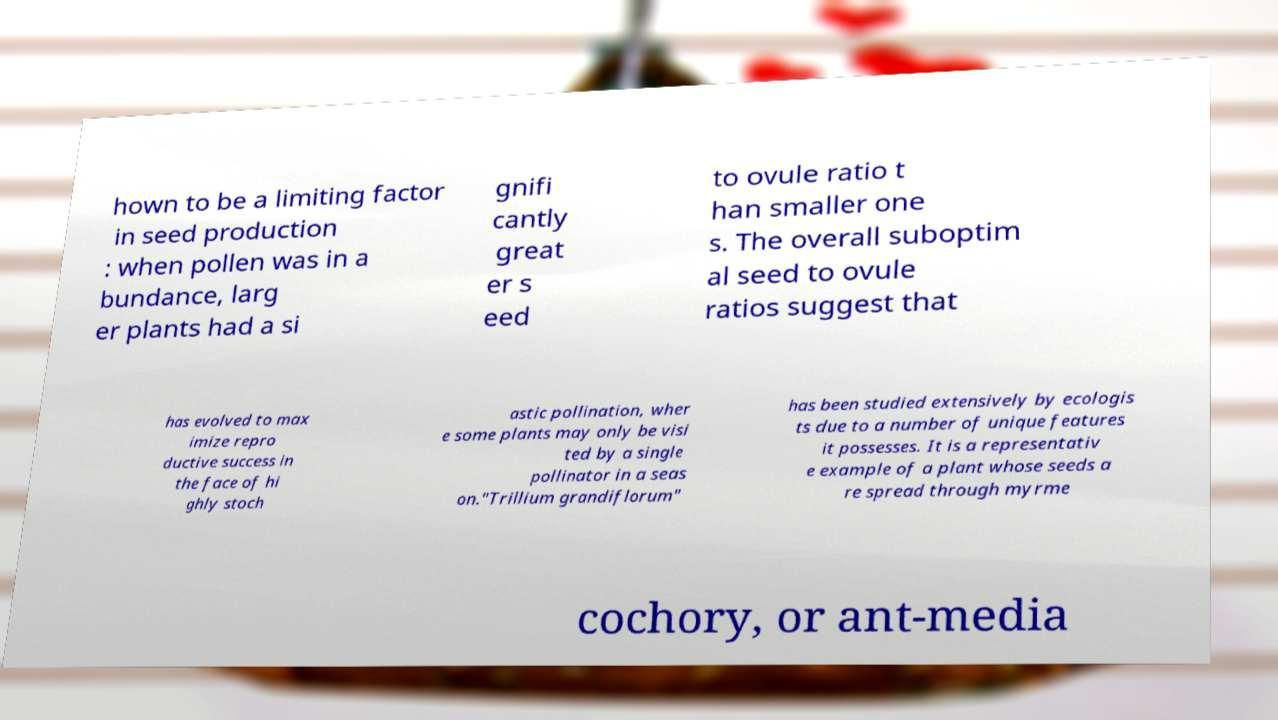What messages or text are displayed in this image? I need them in a readable, typed format. hown to be a limiting factor in seed production : when pollen was in a bundance, larg er plants had a si gnifi cantly great er s eed to ovule ratio t han smaller one s. The overall suboptim al seed to ovule ratios suggest that has evolved to max imize repro ductive success in the face of hi ghly stoch astic pollination, wher e some plants may only be visi ted by a single pollinator in a seas on."Trillium grandiflorum" has been studied extensively by ecologis ts due to a number of unique features it possesses. It is a representativ e example of a plant whose seeds a re spread through myrme cochory, or ant-media 